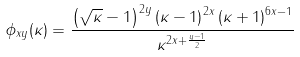Convert formula to latex. <formula><loc_0><loc_0><loc_500><loc_500>\phi _ { x y } ( \kappa ) = \frac { \left ( \sqrt { \kappa } - 1 \right ) ^ { 2 y } \left ( \kappa - 1 \right ) ^ { 2 x } \left ( \kappa + 1 \right ) ^ { 6 x - 1 } } { \kappa ^ { 2 x + \frac { y - 1 } { 2 } } }</formula> 